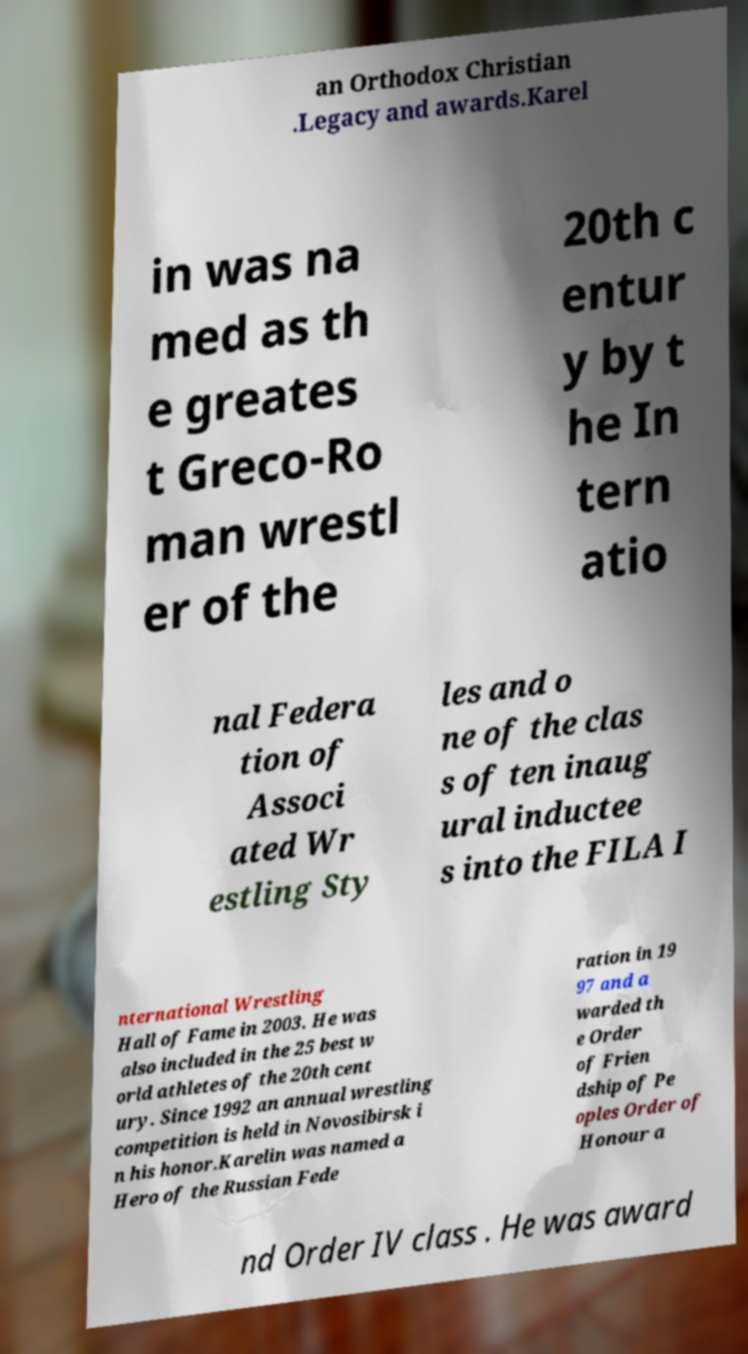Could you assist in decoding the text presented in this image and type it out clearly? an Orthodox Christian .Legacy and awards.Karel in was na med as th e greates t Greco-Ro man wrestl er of the 20th c entur y by t he In tern atio nal Federa tion of Associ ated Wr estling Sty les and o ne of the clas s of ten inaug ural inductee s into the FILA I nternational Wrestling Hall of Fame in 2003. He was also included in the 25 best w orld athletes of the 20th cent ury. Since 1992 an annual wrestling competition is held in Novosibirsk i n his honor.Karelin was named a Hero of the Russian Fede ration in 19 97 and a warded th e Order of Frien dship of Pe oples Order of Honour a nd Order IV class . He was award 